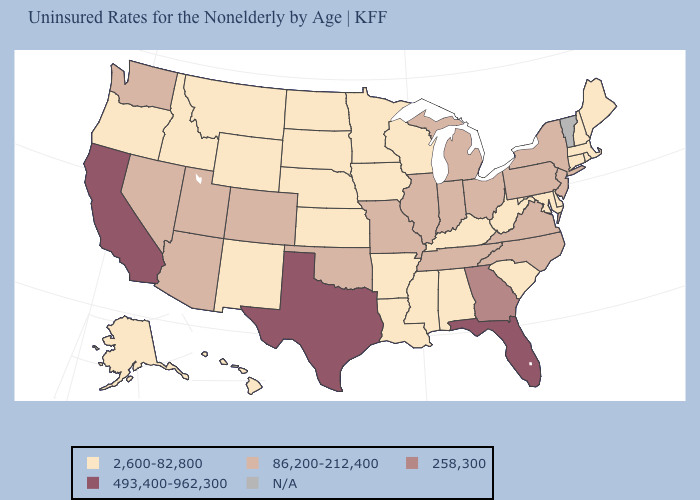Is the legend a continuous bar?
Write a very short answer. No. Does the first symbol in the legend represent the smallest category?
Concise answer only. Yes. Which states have the lowest value in the MidWest?
Quick response, please. Iowa, Kansas, Minnesota, Nebraska, North Dakota, South Dakota, Wisconsin. How many symbols are there in the legend?
Give a very brief answer. 5. Does Utah have the lowest value in the West?
Answer briefly. No. Among the states that border Rhode Island , which have the highest value?
Answer briefly. Connecticut, Massachusetts. What is the value of Rhode Island?
Answer briefly. 2,600-82,800. What is the highest value in states that border Illinois?
Be succinct. 86,200-212,400. What is the highest value in states that border Idaho?
Quick response, please. 86,200-212,400. What is the value of New Hampshire?
Answer briefly. 2,600-82,800. What is the value of Arkansas?
Quick response, please. 2,600-82,800. What is the lowest value in the USA?
Give a very brief answer. 2,600-82,800. Among the states that border Mississippi , which have the highest value?
Be succinct. Tennessee. What is the highest value in states that border Washington?
Short answer required. 2,600-82,800. 